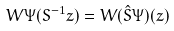<formula> <loc_0><loc_0><loc_500><loc_500>W \Psi ( S ^ { - 1 } z ) = W ( \hat { S } \Psi ) ( z )</formula> 